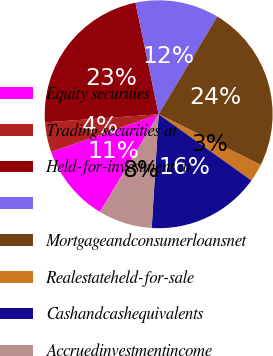<chart> <loc_0><loc_0><loc_500><loc_500><pie_chart><fcel>Equity securities<fcel>Trading securities at<fcel>Held-for-investment at<fcel>Unnamed: 3<fcel>Mortgageandconsumerloansnet<fcel>Realestateheld-for-sale<fcel>Cashandcashequivalents<fcel>Accruedinvestmentincome<nl><fcel>11.02%<fcel>4.24%<fcel>22.88%<fcel>11.86%<fcel>23.73%<fcel>2.54%<fcel>16.1%<fcel>7.63%<nl></chart> 